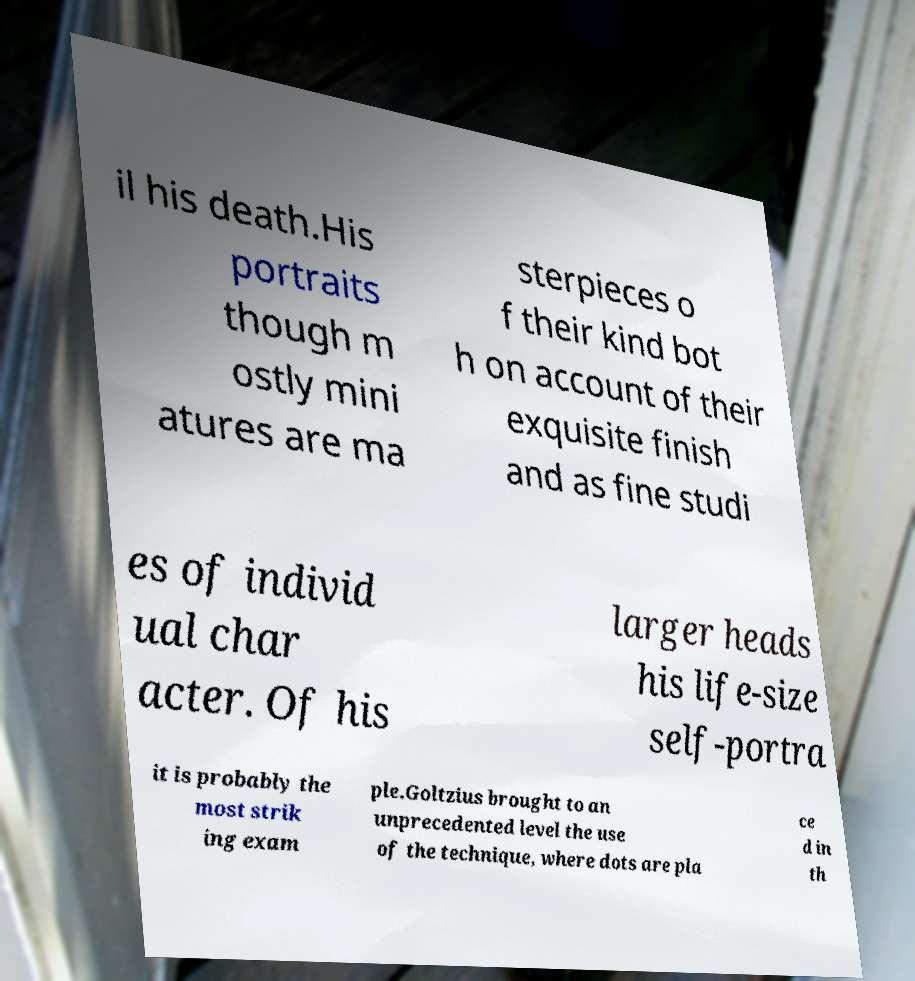Can you read and provide the text displayed in the image?This photo seems to have some interesting text. Can you extract and type it out for me? il his death.His portraits though m ostly mini atures are ma sterpieces o f their kind bot h on account of their exquisite finish and as fine studi es of individ ual char acter. Of his larger heads his life-size self-portra it is probably the most strik ing exam ple.Goltzius brought to an unprecedented level the use of the technique, where dots are pla ce d in th 